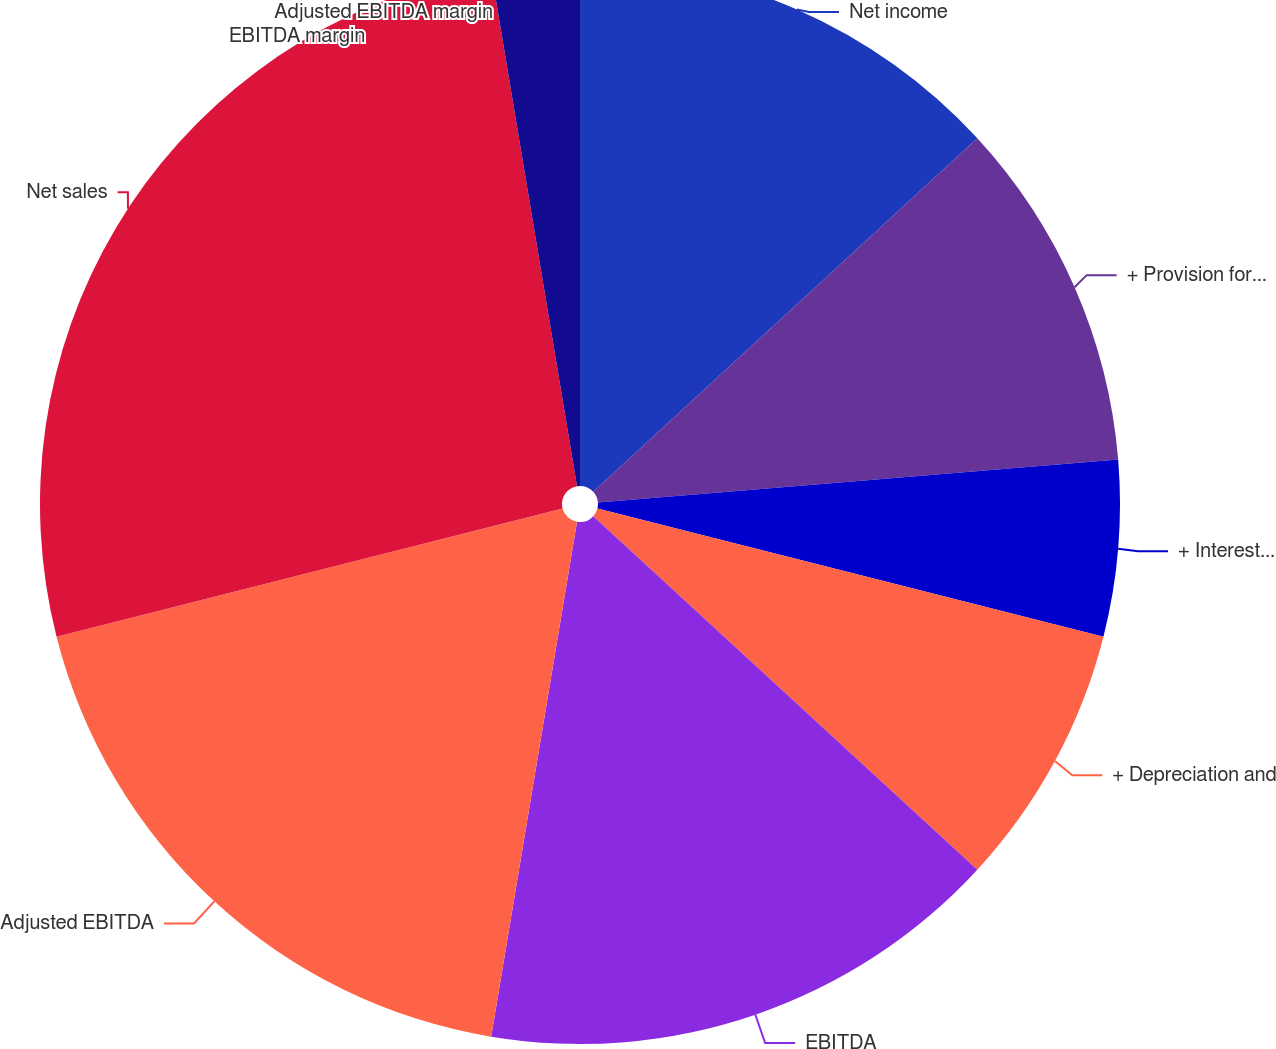Convert chart to OTSL. <chart><loc_0><loc_0><loc_500><loc_500><pie_chart><fcel>Net income<fcel>+ Provision for income taxes<fcel>+ Interest expense<fcel>+ Depreciation and<fcel>EBITDA<fcel>Adjusted EBITDA<fcel>Net sales<fcel>EBITDA margin<fcel>Adjusted EBITDA margin<nl><fcel>13.16%<fcel>10.53%<fcel>5.26%<fcel>7.89%<fcel>15.79%<fcel>18.42%<fcel>26.32%<fcel>0.0%<fcel>2.63%<nl></chart> 